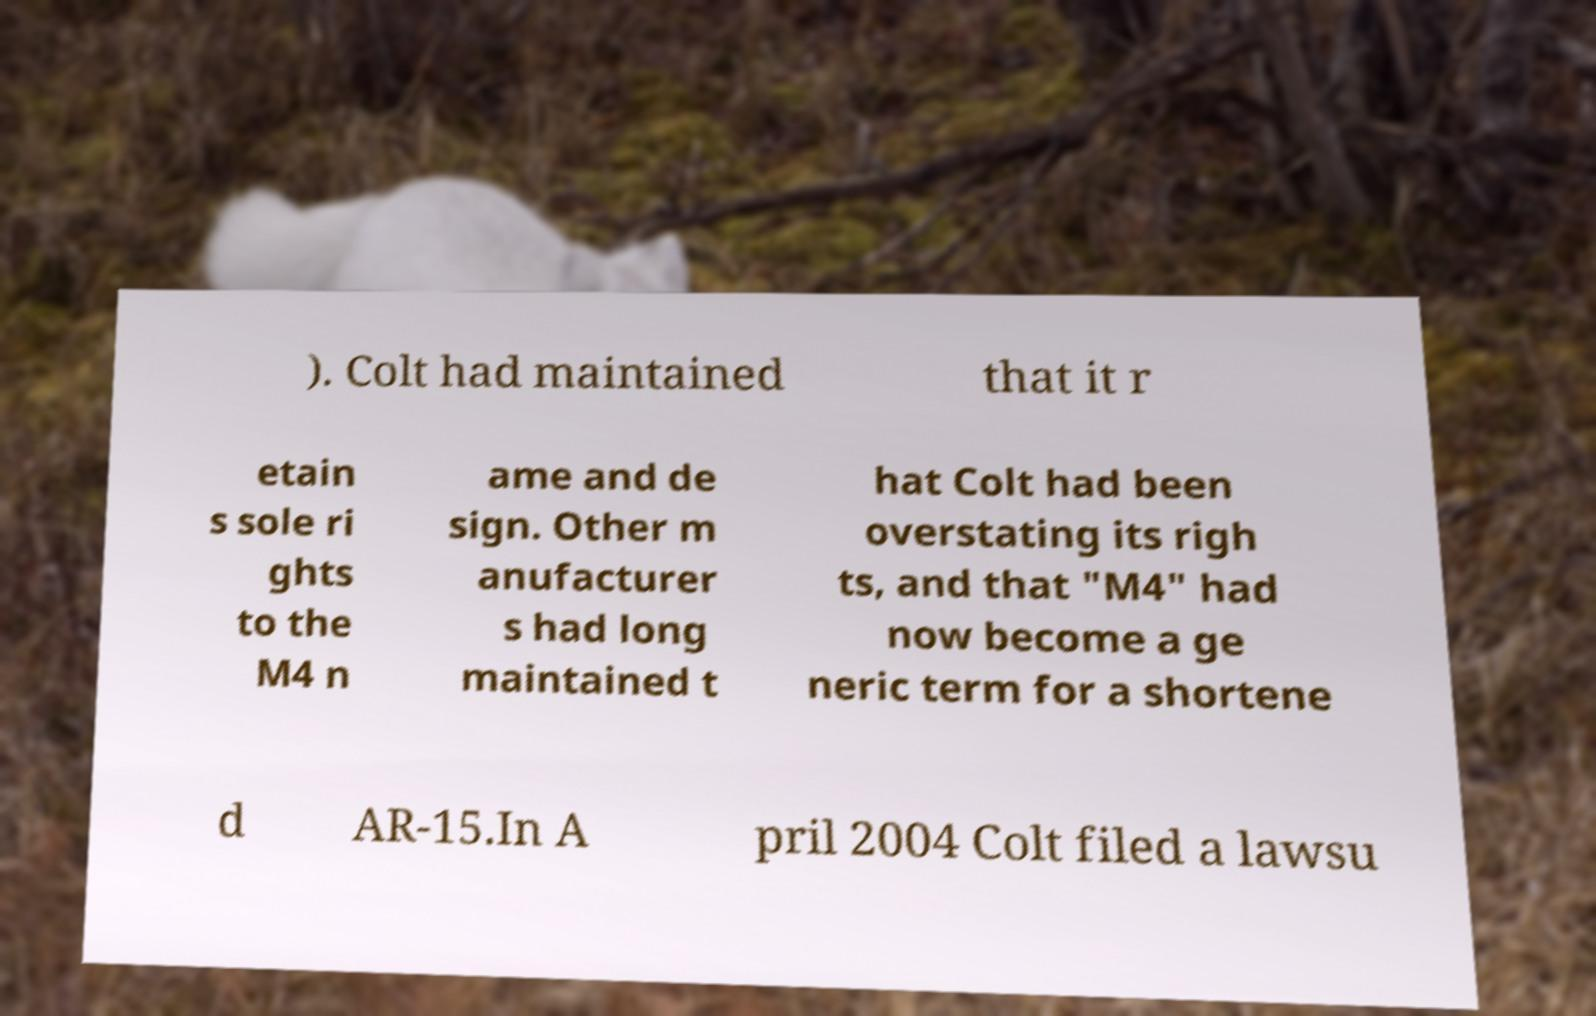For documentation purposes, I need the text within this image transcribed. Could you provide that? ). Colt had maintained that it r etain s sole ri ghts to the M4 n ame and de sign. Other m anufacturer s had long maintained t hat Colt had been overstating its righ ts, and that "M4" had now become a ge neric term for a shortene d AR-15.In A pril 2004 Colt filed a lawsu 